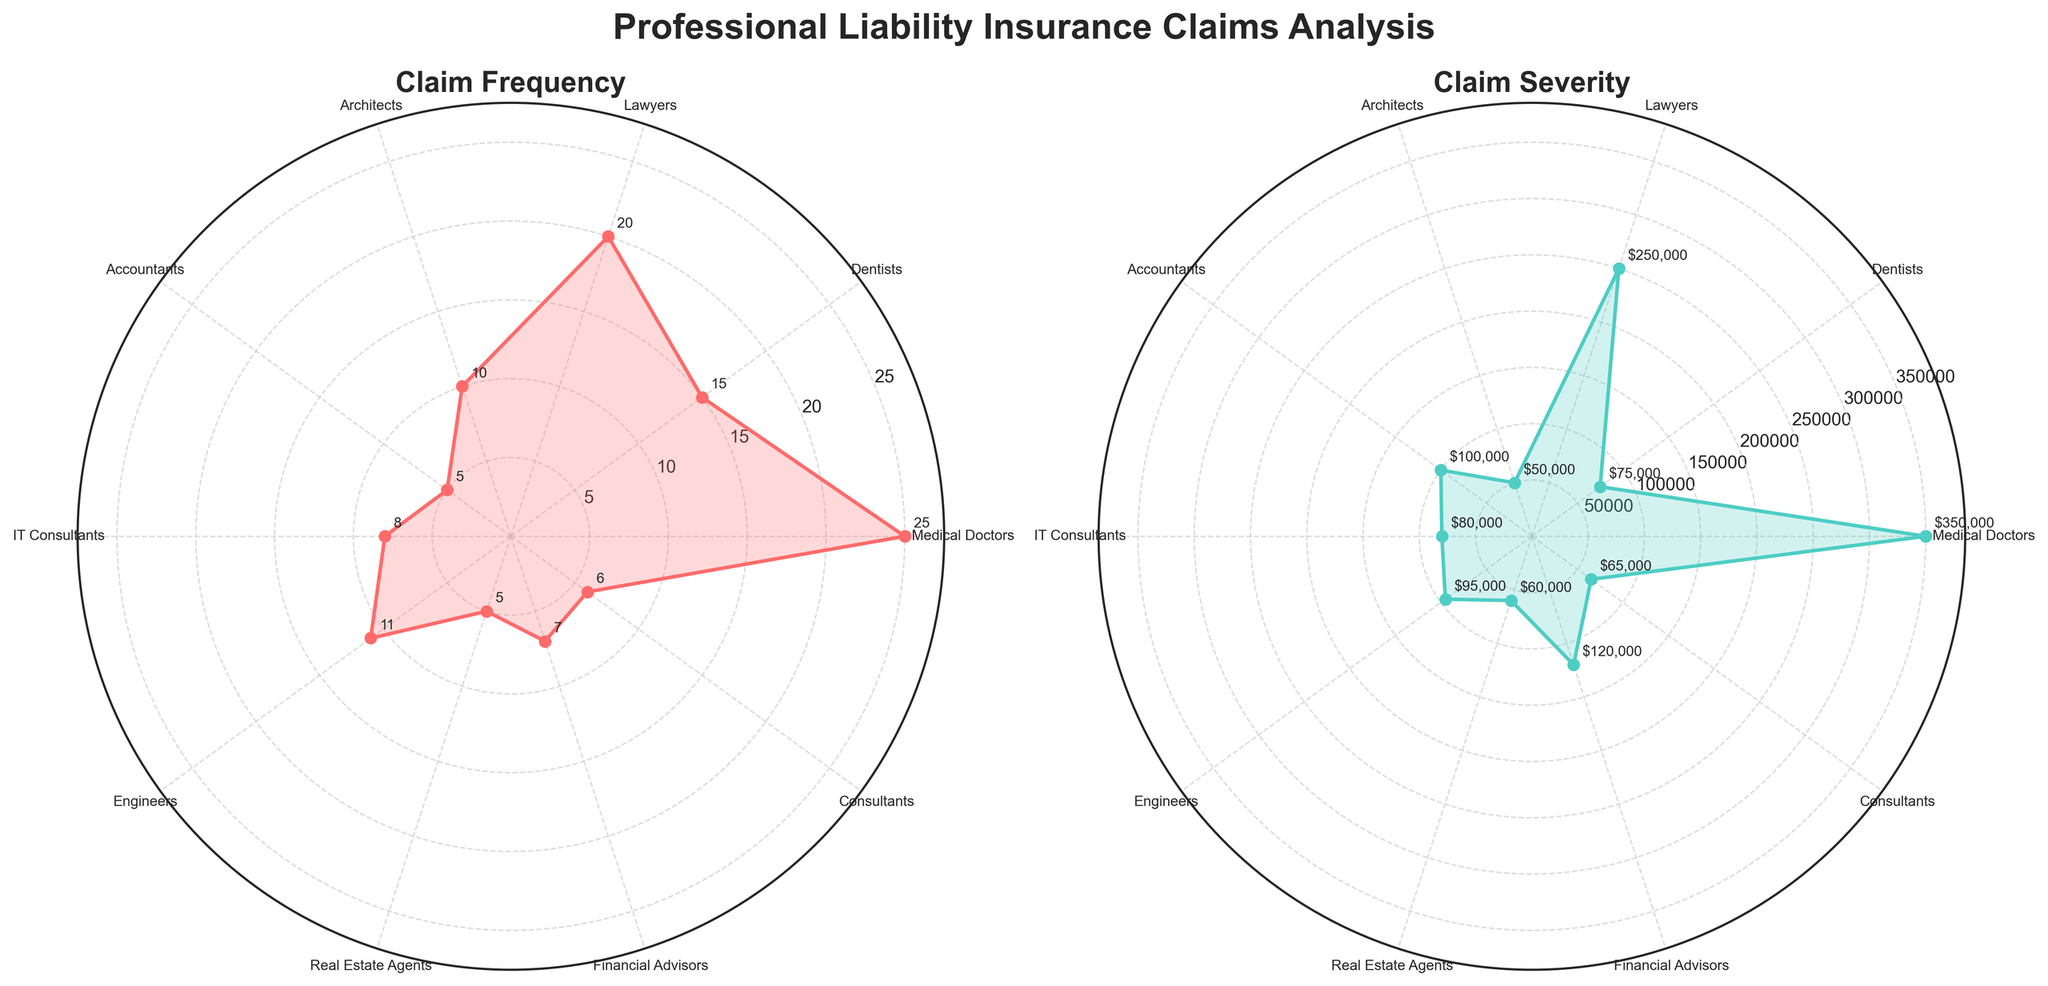What is the title of the left subplot? The title of the left subplot is written at the top of the plot. The text displayed there indicates "Claim Frequency".
Answer: Claim Frequency Which profession has the highest claim frequency? The profession with the highest point on the left radar chart represents the highest claim frequency. According to the plot, "Medical Doctors" have the highest claim frequency.
Answer: Medical Doctors What is the claim severity for IT Consultants? On the right radar chart, the position and annotated value near "IT Consultants" show the claim severity. It's displayed as $"80,000".
Answer: $80,000 Which two professions have the lowest claim frequency? The lowest points on the left radar chart represent the lowest claim frequencies. "Real Estate Agents" and "Accountants" have the lowest values.
Answer: Real Estate Agents and Accountants Compare the claim frequency between Lawyers and Engineers. Which one is higher, and by how much? By checking the annotated values for "Lawyers" and "Engineers" on the left radar chart, "Lawyers" have a claim frequency of 20 while "Engineers" have 11. The difference is 20 - 11 = 9.
Answer: Lawyers, by 9 Which profession has a claim severity closest to 100,000? The annotated values near the professions on the right radar chart help identify this. "Accountants" have a claim severity of $100,000, which matches exactly.
Answer: Accountants What is the average claim frequency for Dentists and Lawyers combined? Add the claim frequencies of Dentists and Lawyers from the left plot: 15 + 20 = 35, then divide by 2 to find the average, which is 35 / 2 = 17.5.
Answer: 17.5 Which profession has a higher claim frequency, IT Consultants or Financial Advisors? By comparing the annotated values on the left radar chart, IT Consultants have a claim frequency of 8 and Financial Advisors have 7. Therefore, IT Consultants have a higher frequency.
Answer: IT Consultants Describe the relationship between claim frequency and severity for Medical Doctors. Medical Doctors have the highest claim frequency at 25 (left chart) and also a high claim severity at $350,000 (right chart). Their higher frequency correlates with their high severity.
Answer: High frequency and high severity Rank these three professions by their claim severity, from highest to lowest: Architects, Engineers, and Consultants. By checking the annotated values on the right radar chart: Architects have $50,000, Engineers have $95,000, and Consultants have $65,000. The ranking from highest to lowest is Engineers > Consultants > Architects.
Answer: Engineers > Consultants > Architects 